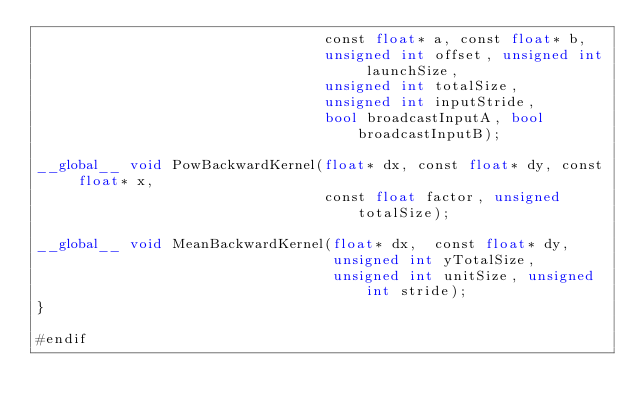<code> <loc_0><loc_0><loc_500><loc_500><_Cuda_>                                  const float* a, const float* b,
                                  unsigned int offset, unsigned int launchSize,
                                  unsigned int totalSize,
                                  unsigned int inputStride,
                                  bool broadcastInputA, bool broadcastInputB);

__global__ void PowBackwardKernel(float* dx, const float* dy, const float* x,
                                  const float factor, unsigned totalSize);

__global__ void MeanBackwardKernel(float* dx,  const float* dy,
                                   unsigned int yTotalSize,
                                   unsigned int unitSize, unsigned int stride);
}

#endif
</code> 